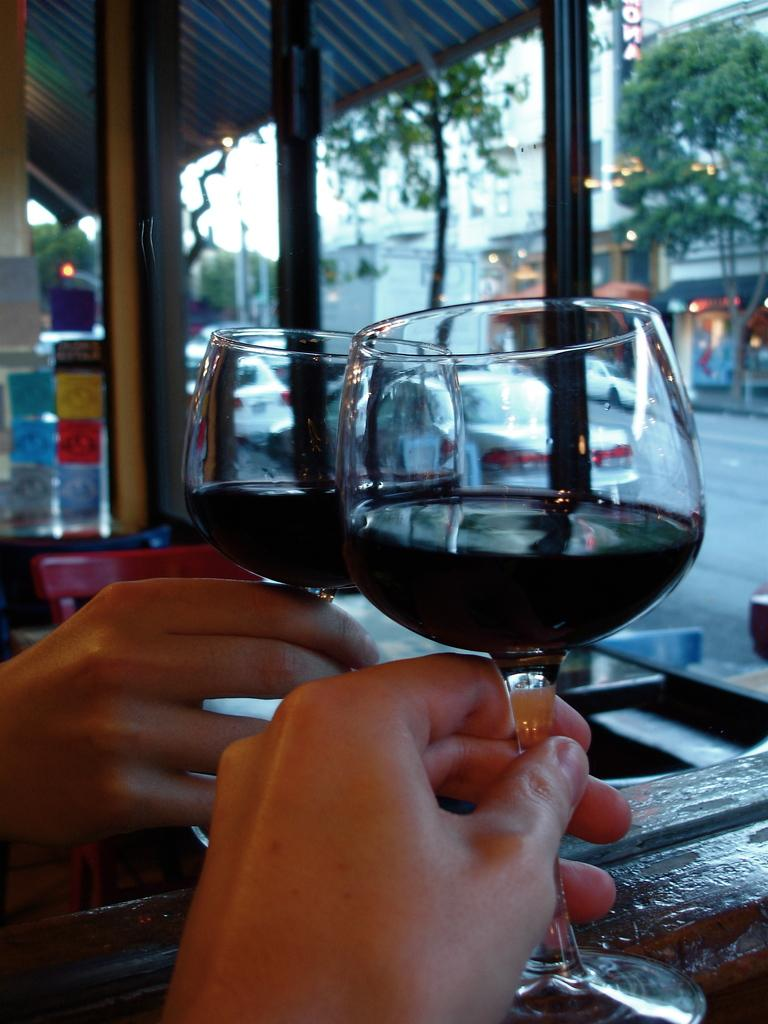How many people are present in the image? There are two people in the image. What are the people holding in their hands? The two people are holding glasses. What can be seen in the background of the image? There are vehicles, stalls, buildings, trees with green color, and the sky in white color in the background of the image. What type of crow is sitting on the roof in the image? There is no crow or roof present in the image. How many balloons are tied to the tree in the image? There are no balloons present in the image. 